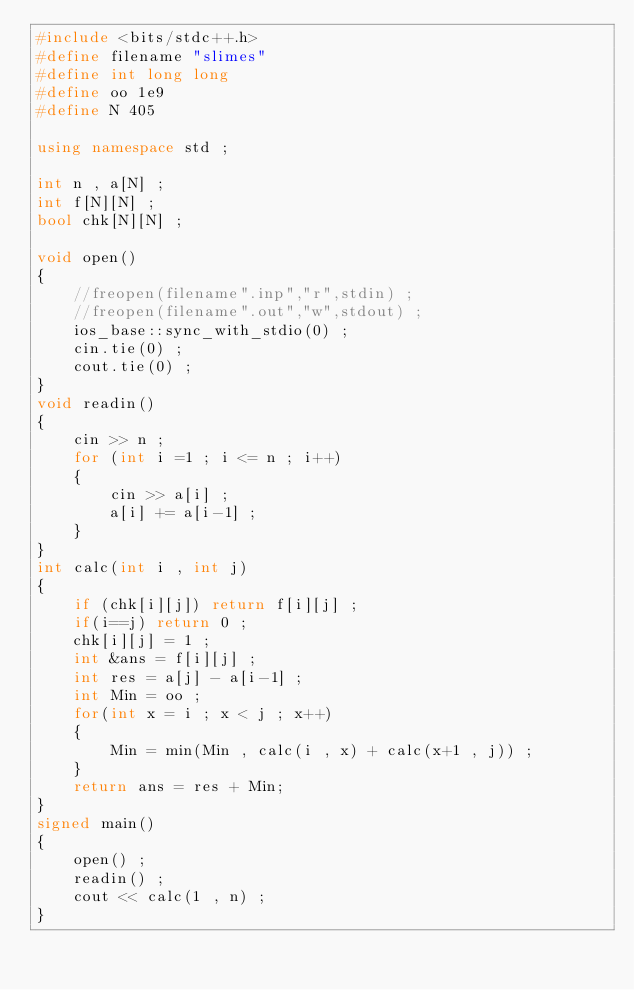<code> <loc_0><loc_0><loc_500><loc_500><_C++_>#include <bits/stdc++.h>
#define filename "slimes"
#define int long long
#define oo 1e9
#define N 405 

using namespace std ;

int n , a[N] ;
int f[N][N] ;
bool chk[N][N] ;

void open()
{
    //freopen(filename".inp","r",stdin) ;
    //freopen(filename".out","w",stdout) ;
    ios_base::sync_with_stdio(0) ;
    cin.tie(0) ;
    cout.tie(0) ;
}
void readin() 
{
    cin >> n ;
    for (int i =1 ; i <= n ; i++)
    {
        cin >> a[i] ;
        a[i] += a[i-1] ;
    }
}
int calc(int i , int j)
{
    if (chk[i][j]) return f[i][j] ;
    if(i==j) return 0 ;
    chk[i][j] = 1 ;
    int &ans = f[i][j] ;
    int res = a[j] - a[i-1] ;
    int Min = oo ;
    for(int x = i ; x < j ; x++)
    {
        Min = min(Min , calc(i , x) + calc(x+1 , j)) ;
    }
    return ans = res + Min;
}
signed main()
{
    open() ;
    readin() ;
    cout << calc(1 , n) ;
}</code> 